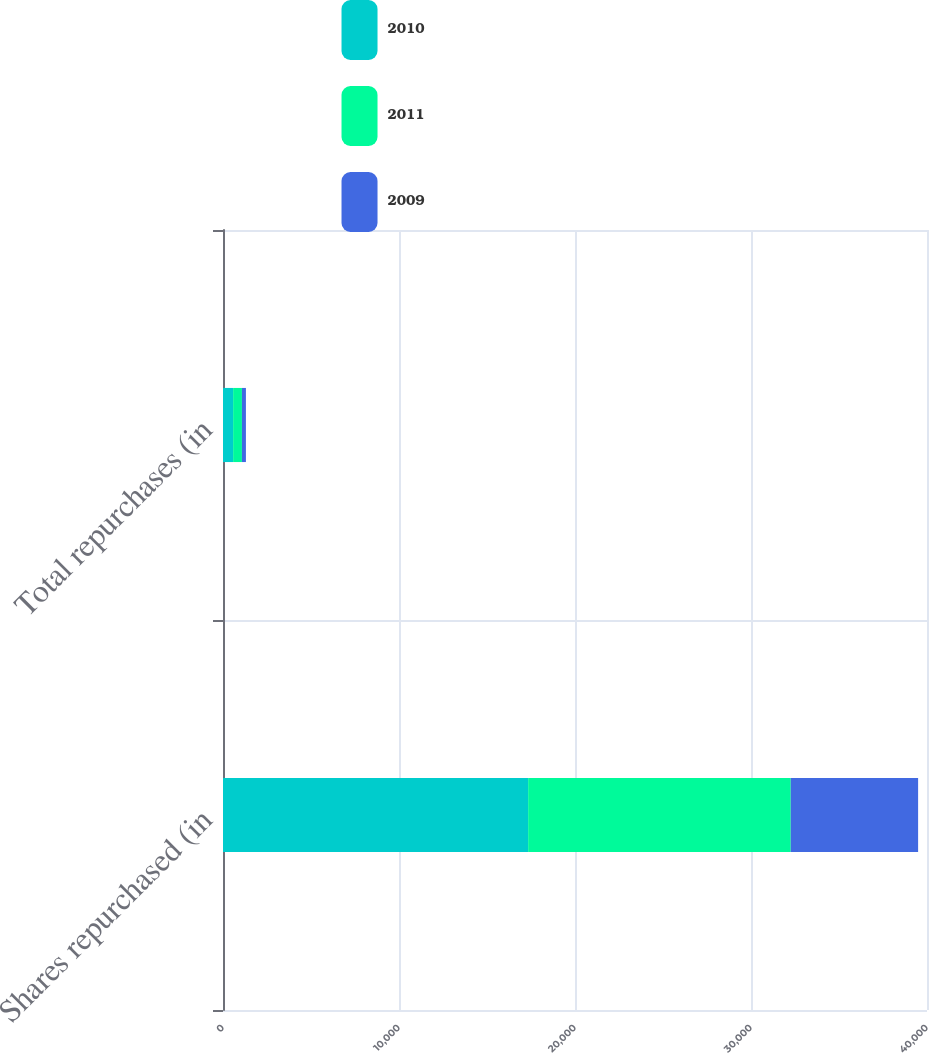<chart> <loc_0><loc_0><loc_500><loc_500><stacked_bar_chart><ecel><fcel>Shares repurchased (in<fcel>Total repurchases (in<nl><fcel>2010<fcel>17338<fcel>575<nl><fcel>2011<fcel>14920<fcel>501<nl><fcel>2009<fcel>7237<fcel>226<nl></chart> 